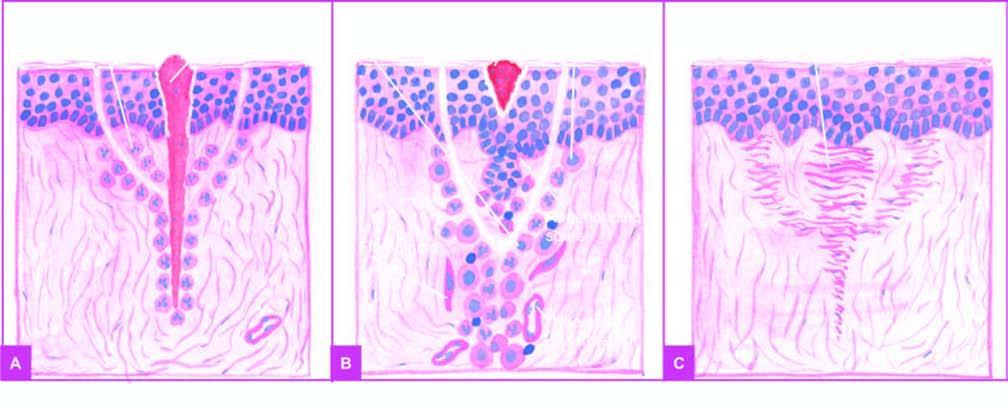when does removal of suture result in?
Answer the question using a single word or phrase. Around 7th day 